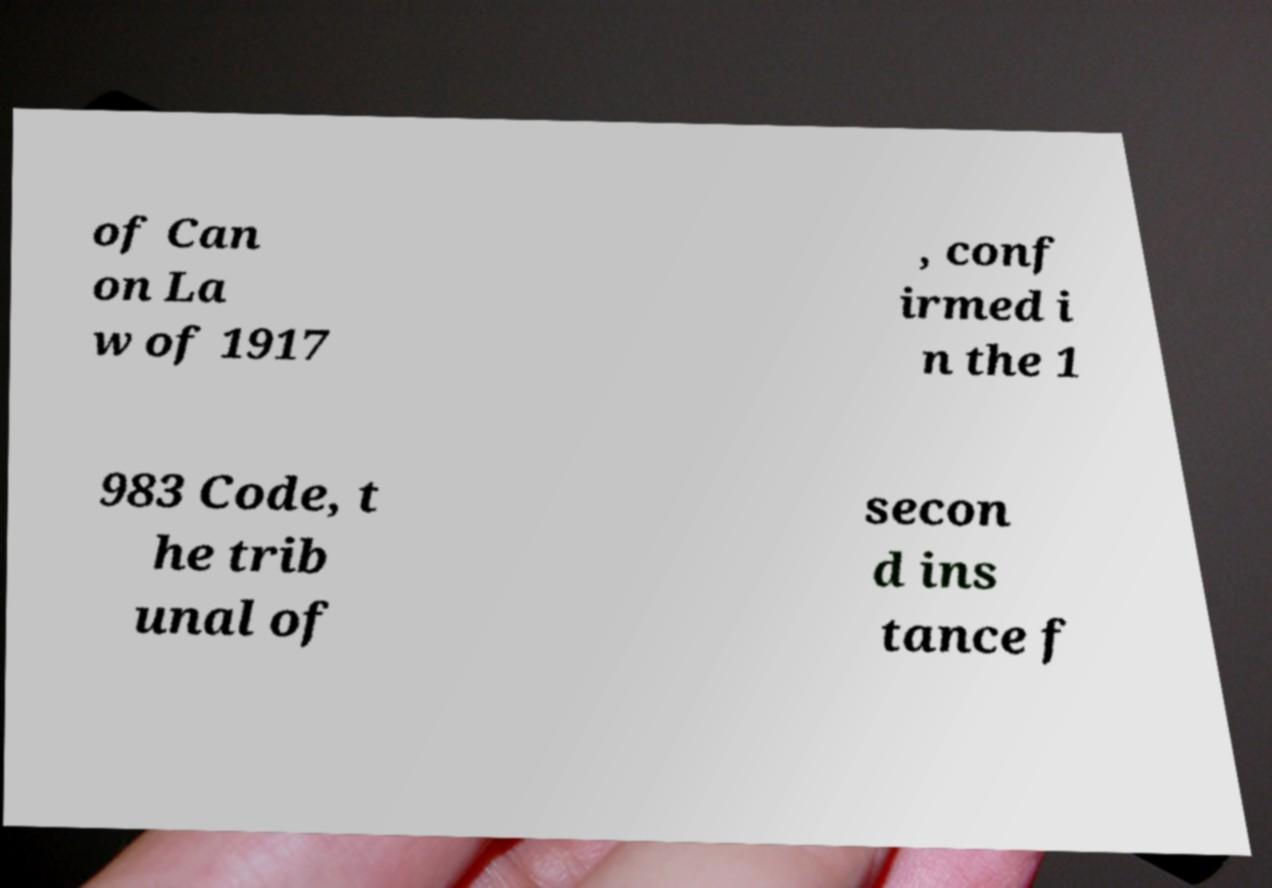What messages or text are displayed in this image? I need them in a readable, typed format. of Can on La w of 1917 , conf irmed i n the 1 983 Code, t he trib unal of secon d ins tance f 